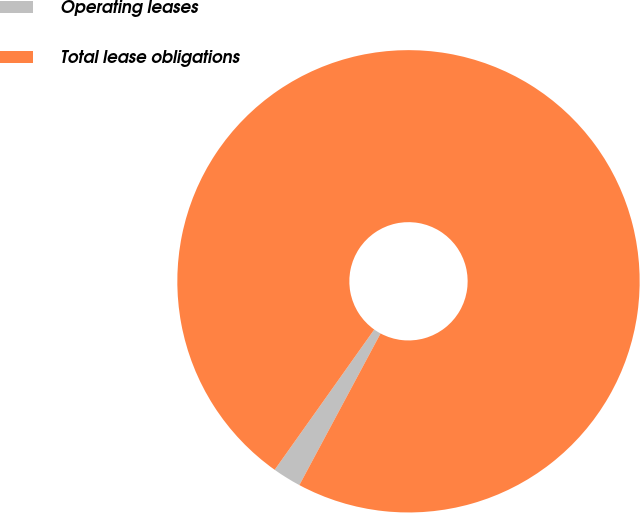<chart> <loc_0><loc_0><loc_500><loc_500><pie_chart><fcel>Operating leases<fcel>Total lease obligations<nl><fcel>2.0%<fcel>98.0%<nl></chart> 